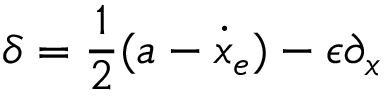Convert formula to latex. <formula><loc_0><loc_0><loc_500><loc_500>\delta = \frac { 1 } { 2 } ( a - \dot { x } _ { e } ) - \epsilon \partial _ { x }</formula> 